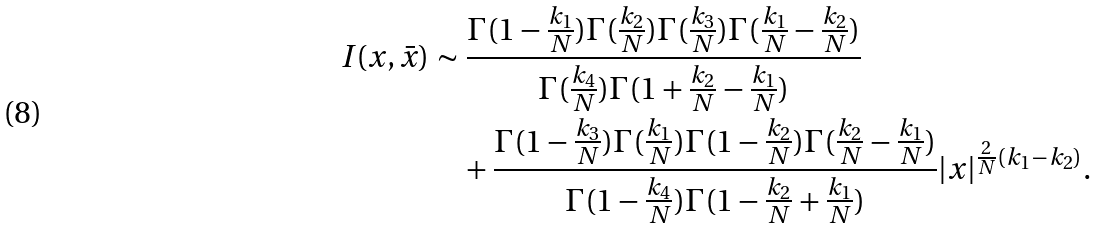Convert formula to latex. <formula><loc_0><loc_0><loc_500><loc_500>I ( x , \bar { x } ) & \sim \frac { \Gamma ( 1 - \frac { k _ { 1 } } { N } ) \Gamma ( \frac { k _ { 2 } } { N } ) \Gamma ( \frac { k _ { 3 } } { N } ) \Gamma ( \frac { k _ { 1 } } { N } - \frac { k _ { 2 } } { N } ) } { \Gamma ( \frac { k _ { 4 } } { N } ) \Gamma ( 1 + \frac { k _ { 2 } } { N } - \frac { k _ { 1 } } { N } ) } \\ & \quad + \frac { \Gamma ( 1 - \frac { k _ { 3 } } { N } ) \Gamma ( \frac { k _ { 1 } } { N } ) \Gamma ( 1 - \frac { k _ { 2 } } { N } ) \Gamma ( \frac { k _ { 2 } } { N } - \frac { k _ { 1 } } { N } ) } { \Gamma ( 1 - \frac { k _ { 4 } } { N } ) \Gamma ( 1 - \frac { k _ { 2 } } { N } + \frac { k _ { 1 } } { N } ) } | x | ^ { \frac { 2 } { N } ( k _ { 1 } - k _ { 2 } ) } .</formula> 